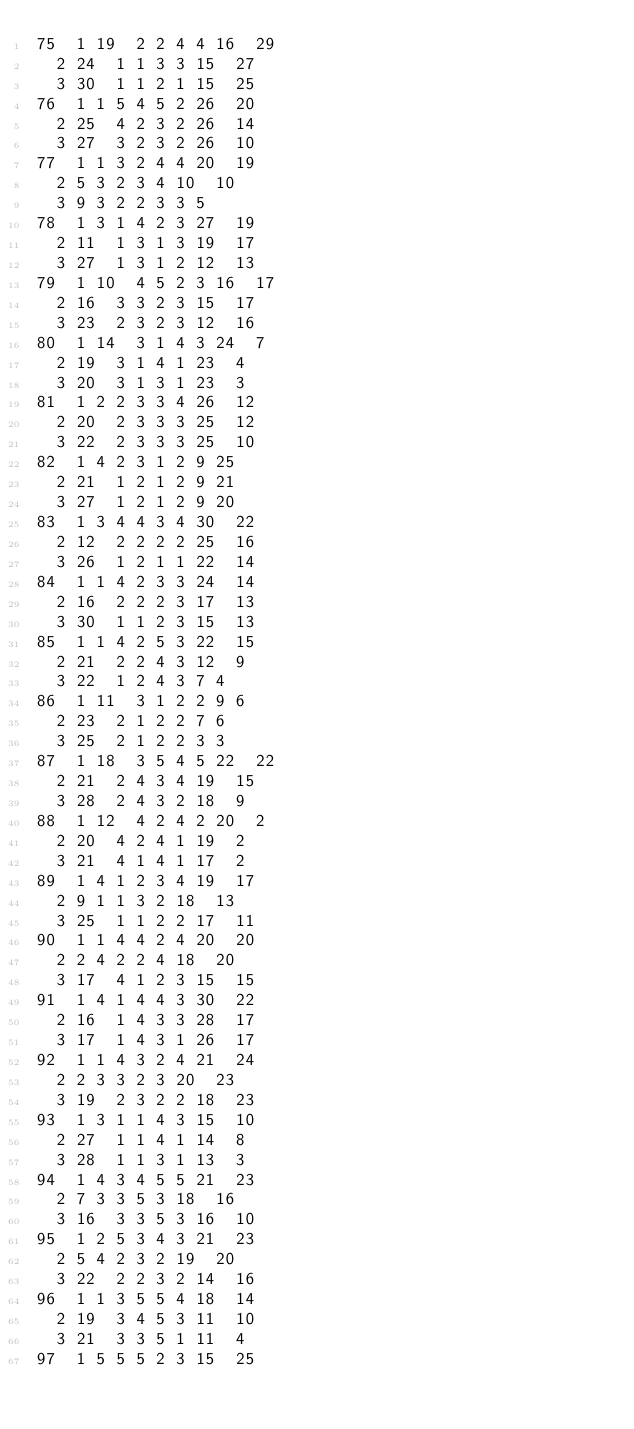<code> <loc_0><loc_0><loc_500><loc_500><_ObjectiveC_>75	1	19	2	2	4	4	16	29	
	2	24	1	1	3	3	15	27	
	3	30	1	1	2	1	15	25	
76	1	1	5	4	5	2	26	20	
	2	25	4	2	3	2	26	14	
	3	27	3	2	3	2	26	10	
77	1	1	3	2	4	4	20	19	
	2	5	3	2	3	4	10	10	
	3	9	3	2	2	3	3	5	
78	1	3	1	4	2	3	27	19	
	2	11	1	3	1	3	19	17	
	3	27	1	3	1	2	12	13	
79	1	10	4	5	2	3	16	17	
	2	16	3	3	2	3	15	17	
	3	23	2	3	2	3	12	16	
80	1	14	3	1	4	3	24	7	
	2	19	3	1	4	1	23	4	
	3	20	3	1	3	1	23	3	
81	1	2	2	3	3	4	26	12	
	2	20	2	3	3	3	25	12	
	3	22	2	3	3	3	25	10	
82	1	4	2	3	1	2	9	25	
	2	21	1	2	1	2	9	21	
	3	27	1	2	1	2	9	20	
83	1	3	4	4	3	4	30	22	
	2	12	2	2	2	2	25	16	
	3	26	1	2	1	1	22	14	
84	1	1	4	2	3	3	24	14	
	2	16	2	2	2	3	17	13	
	3	30	1	1	2	3	15	13	
85	1	1	4	2	5	3	22	15	
	2	21	2	2	4	3	12	9	
	3	22	1	2	4	3	7	4	
86	1	11	3	1	2	2	9	6	
	2	23	2	1	2	2	7	6	
	3	25	2	1	2	2	3	3	
87	1	18	3	5	4	5	22	22	
	2	21	2	4	3	4	19	15	
	3	28	2	4	3	2	18	9	
88	1	12	4	2	4	2	20	2	
	2	20	4	2	4	1	19	2	
	3	21	4	1	4	1	17	2	
89	1	4	1	2	3	4	19	17	
	2	9	1	1	3	2	18	13	
	3	25	1	1	2	2	17	11	
90	1	1	4	4	2	4	20	20	
	2	2	4	2	2	4	18	20	
	3	17	4	1	2	3	15	15	
91	1	4	1	4	4	3	30	22	
	2	16	1	4	3	3	28	17	
	3	17	1	4	3	1	26	17	
92	1	1	4	3	2	4	21	24	
	2	2	3	3	2	3	20	23	
	3	19	2	3	2	2	18	23	
93	1	3	1	1	4	3	15	10	
	2	27	1	1	4	1	14	8	
	3	28	1	1	3	1	13	3	
94	1	4	3	4	5	5	21	23	
	2	7	3	3	5	3	18	16	
	3	16	3	3	5	3	16	10	
95	1	2	5	3	4	3	21	23	
	2	5	4	2	3	2	19	20	
	3	22	2	2	3	2	14	16	
96	1	1	3	5	5	4	18	14	
	2	19	3	4	5	3	11	10	
	3	21	3	3	5	1	11	4	
97	1	5	5	5	2	3	15	25	</code> 